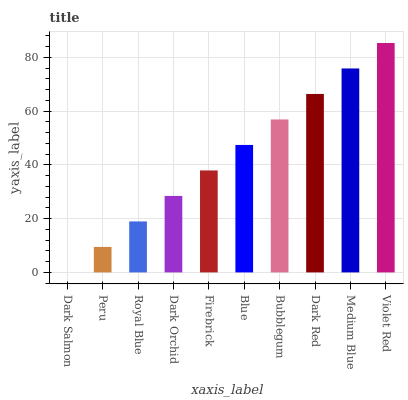Is Dark Salmon the minimum?
Answer yes or no. Yes. Is Violet Red the maximum?
Answer yes or no. Yes. Is Peru the minimum?
Answer yes or no. No. Is Peru the maximum?
Answer yes or no. No. Is Peru greater than Dark Salmon?
Answer yes or no. Yes. Is Dark Salmon less than Peru?
Answer yes or no. Yes. Is Dark Salmon greater than Peru?
Answer yes or no. No. Is Peru less than Dark Salmon?
Answer yes or no. No. Is Blue the high median?
Answer yes or no. Yes. Is Firebrick the low median?
Answer yes or no. Yes. Is Peru the high median?
Answer yes or no. No. Is Dark Red the low median?
Answer yes or no. No. 